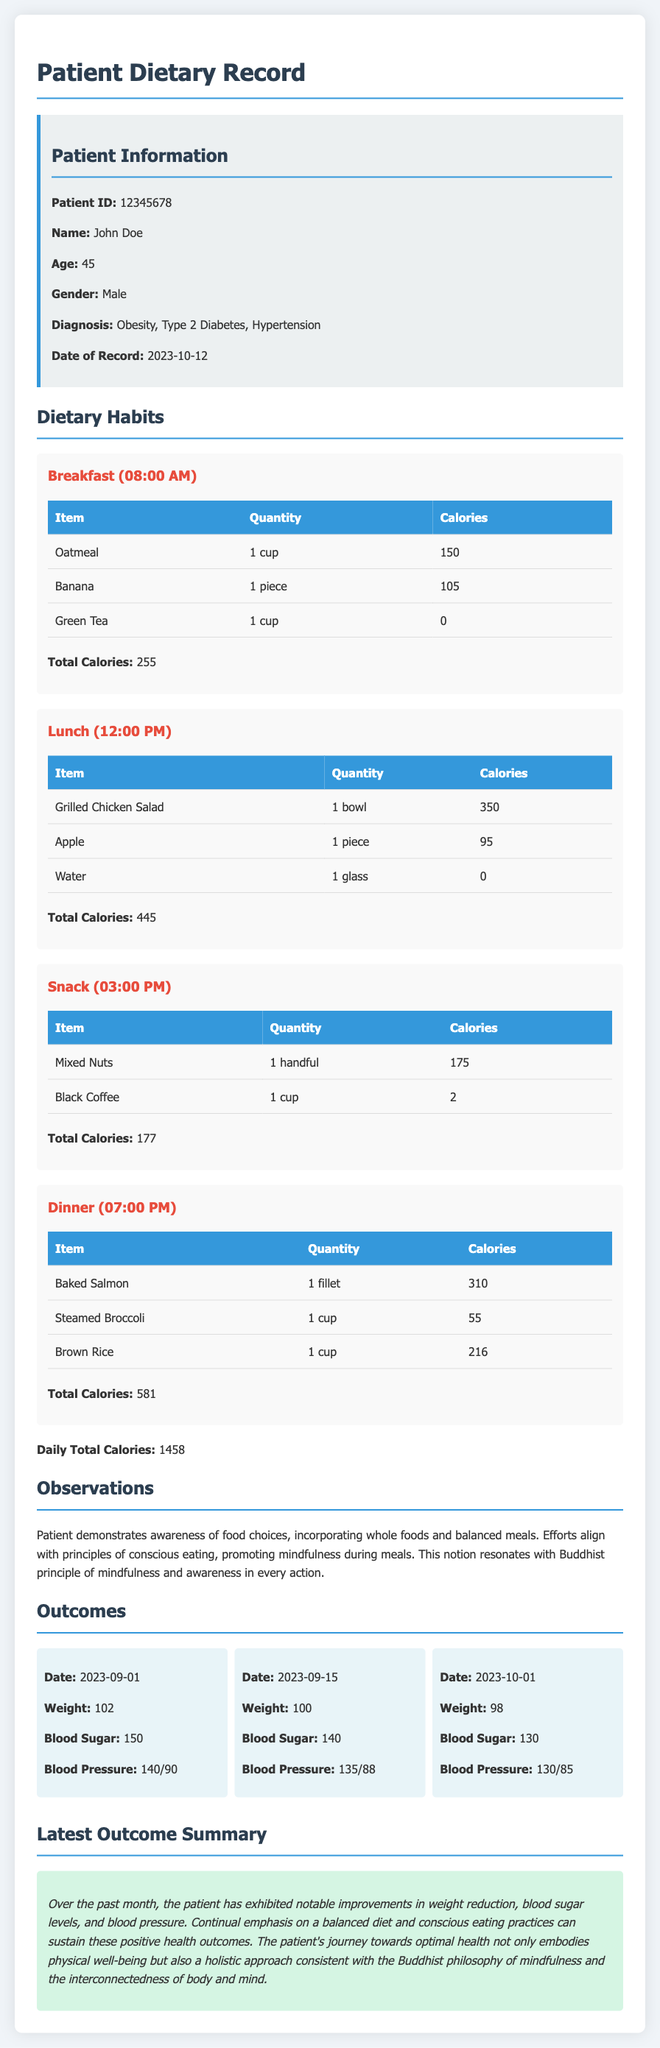What is the patient's name? The patient's name is provided in the patient information section of the document.
Answer: John Doe What is the total calorie intake for lunch? The total calories for lunch can be found in the meal section for lunch with the detailed items listed.
Answer: 445 What is the diagnosis of the patient? The patient's diagnosis is stated in the patient information section.
Answer: Obesity, Type 2 Diabetes, Hypertension What was the patient's weight on 2023-09-15? The patient's weight on that date is presented in the outcomes section.
Answer: 100 Which beverage is consumed during breakfast? The beverages consumed during breakfast are listed in the breakfast meal section.
Answer: Green Tea What is the total calorie intake for the day? The daily total calories are summed up and presented at the end of the meal section.
Answer: 1458 What is the blood sugar level on 2023-10-01? The blood sugar level is recorded in the outcomes section for that specific date.
Answer: 130 How many meals are documented in the record? The meals are listed in the dietary habits section, and counting them gives the total.
Answer: 4 What principle does the patient's dietary approach resonate with? The last paragraph mentions a specific principle that aligns with the patient's dietary habits.
Answer: Mindfulness 